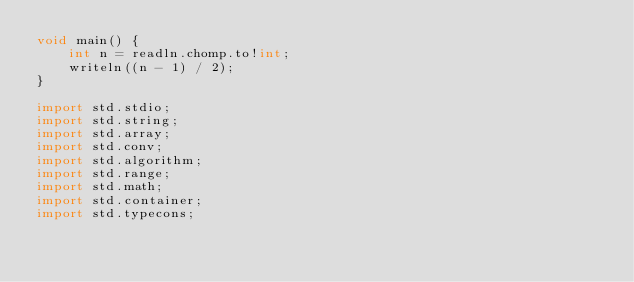<code> <loc_0><loc_0><loc_500><loc_500><_D_>void main() {
    int n = readln.chomp.to!int;
    writeln((n - 1) / 2);
}

import std.stdio;
import std.string;
import std.array;
import std.conv;
import std.algorithm;
import std.range;
import std.math;
import std.container;
import std.typecons;</code> 